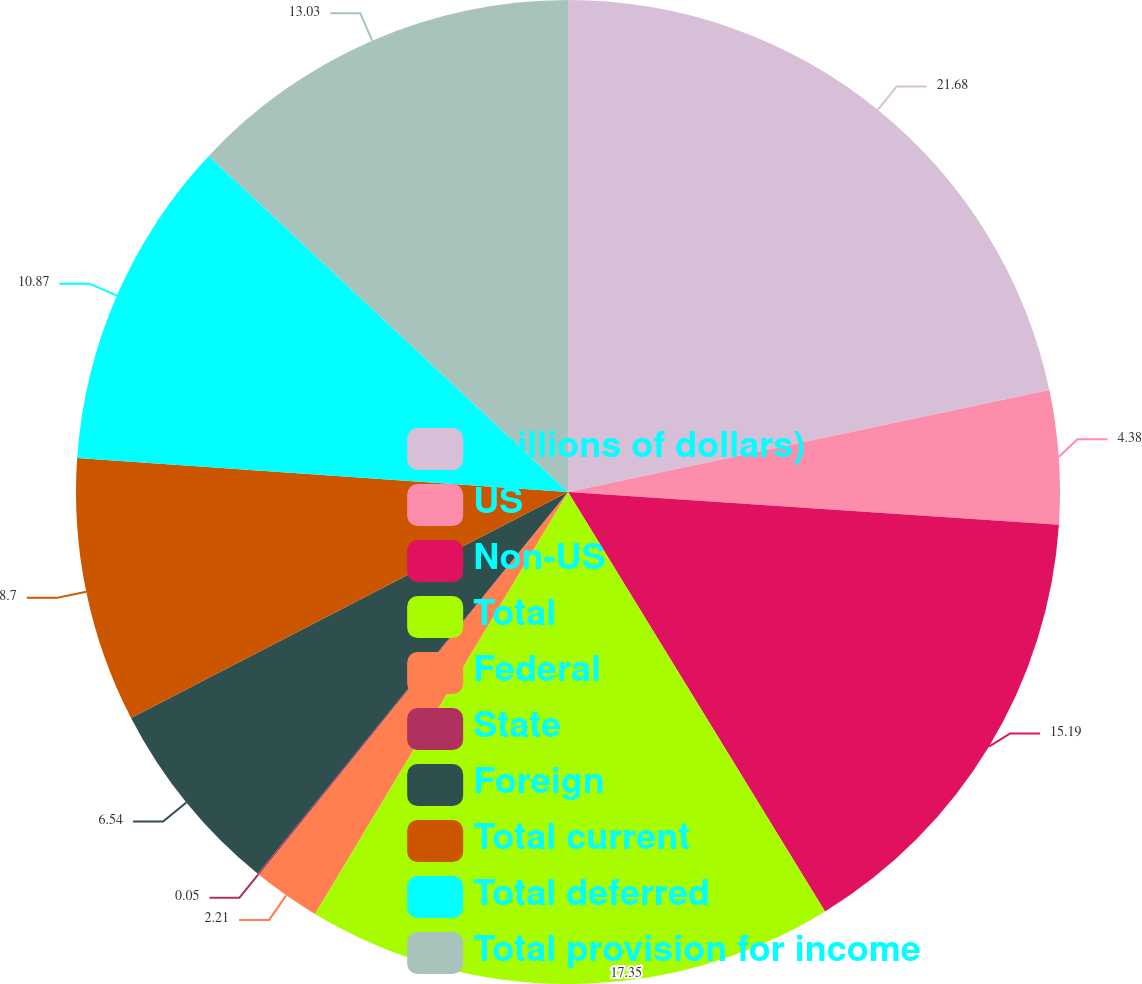Convert chart to OTSL. <chart><loc_0><loc_0><loc_500><loc_500><pie_chart><fcel>(millions of dollars)<fcel>US<fcel>Non-US<fcel>Total<fcel>Federal<fcel>State<fcel>Foreign<fcel>Total current<fcel>Total deferred<fcel>Total provision for income<nl><fcel>21.68%<fcel>4.38%<fcel>15.19%<fcel>17.35%<fcel>2.21%<fcel>0.05%<fcel>6.54%<fcel>8.7%<fcel>10.87%<fcel>13.03%<nl></chart> 